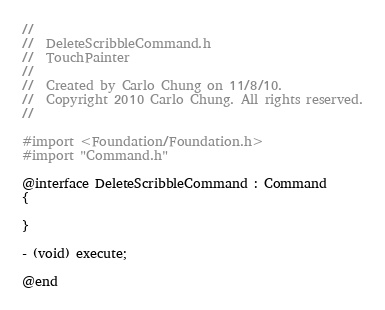<code> <loc_0><loc_0><loc_500><loc_500><_C_>//
//  DeleteScribbleCommand.h
//  TouchPainter
//
//  Created by Carlo Chung on 11/8/10.
//  Copyright 2010 Carlo Chung. All rights reserved.
//

#import <Foundation/Foundation.h>
#import "Command.h"

@interface DeleteScribbleCommand : Command
{

}

- (void) execute;

@end
</code> 